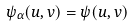Convert formula to latex. <formula><loc_0><loc_0><loc_500><loc_500>\psi _ { \alpha } ( u , v ) = \psi ( u , v )</formula> 